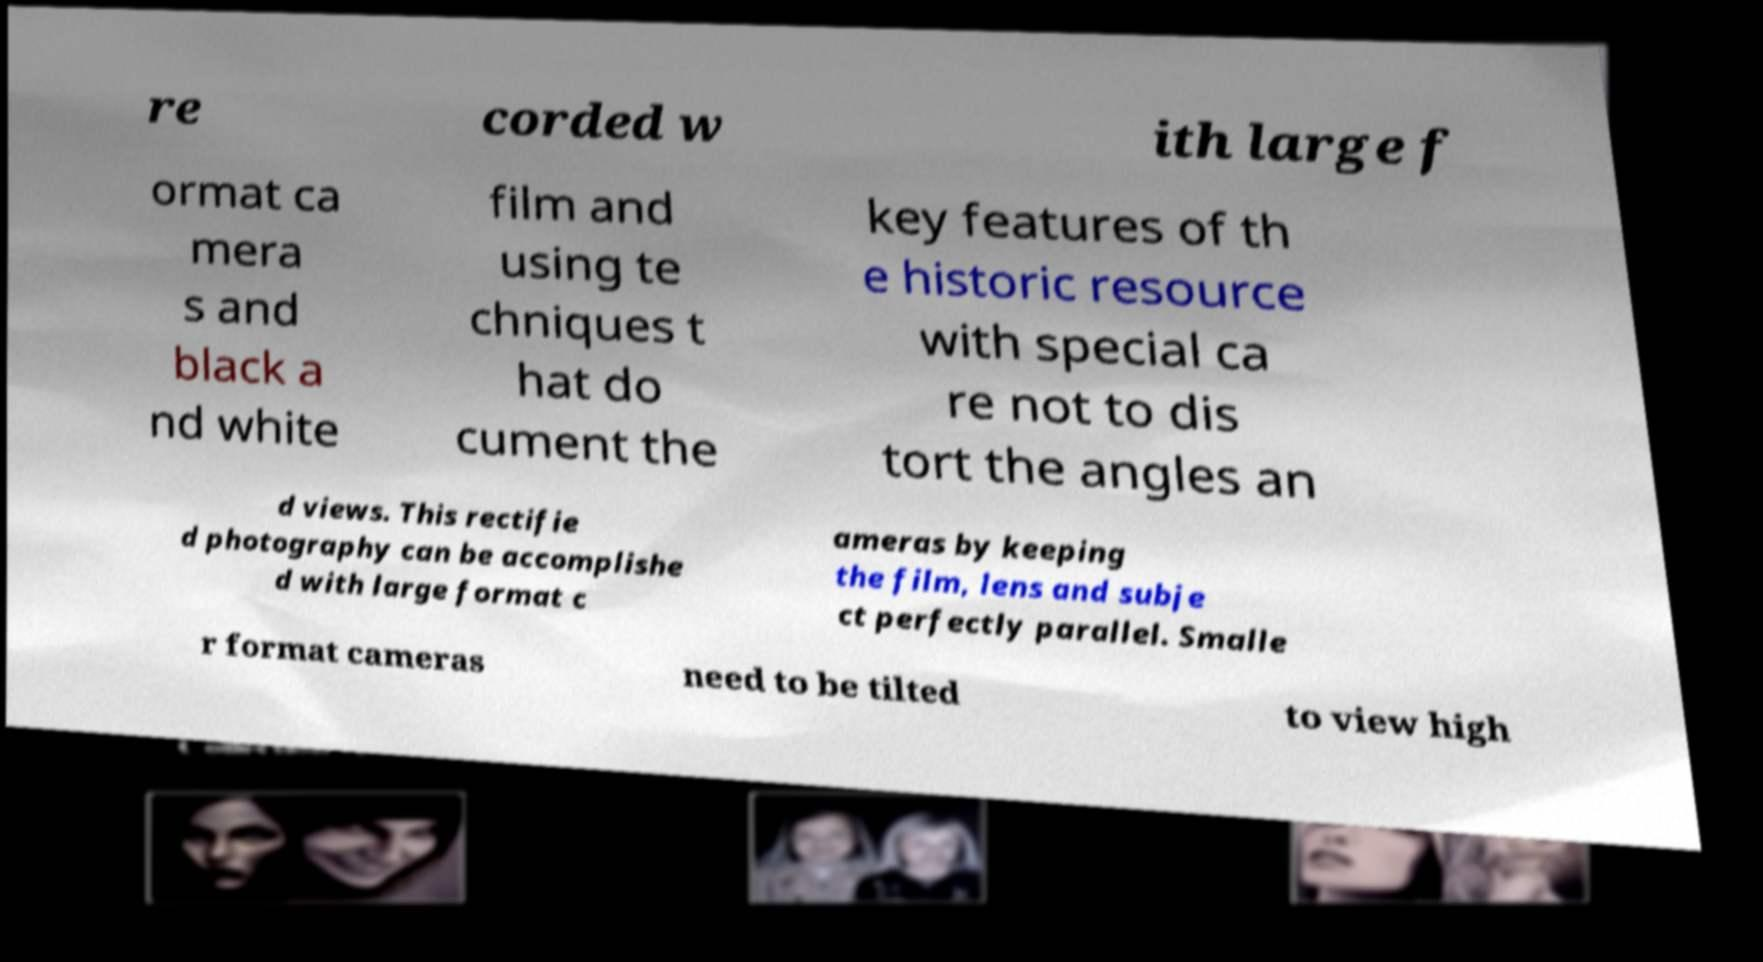Please identify and transcribe the text found in this image. re corded w ith large f ormat ca mera s and black a nd white film and using te chniques t hat do cument the key features of th e historic resource with special ca re not to dis tort the angles an d views. This rectifie d photography can be accomplishe d with large format c ameras by keeping the film, lens and subje ct perfectly parallel. Smalle r format cameras need to be tilted to view high 